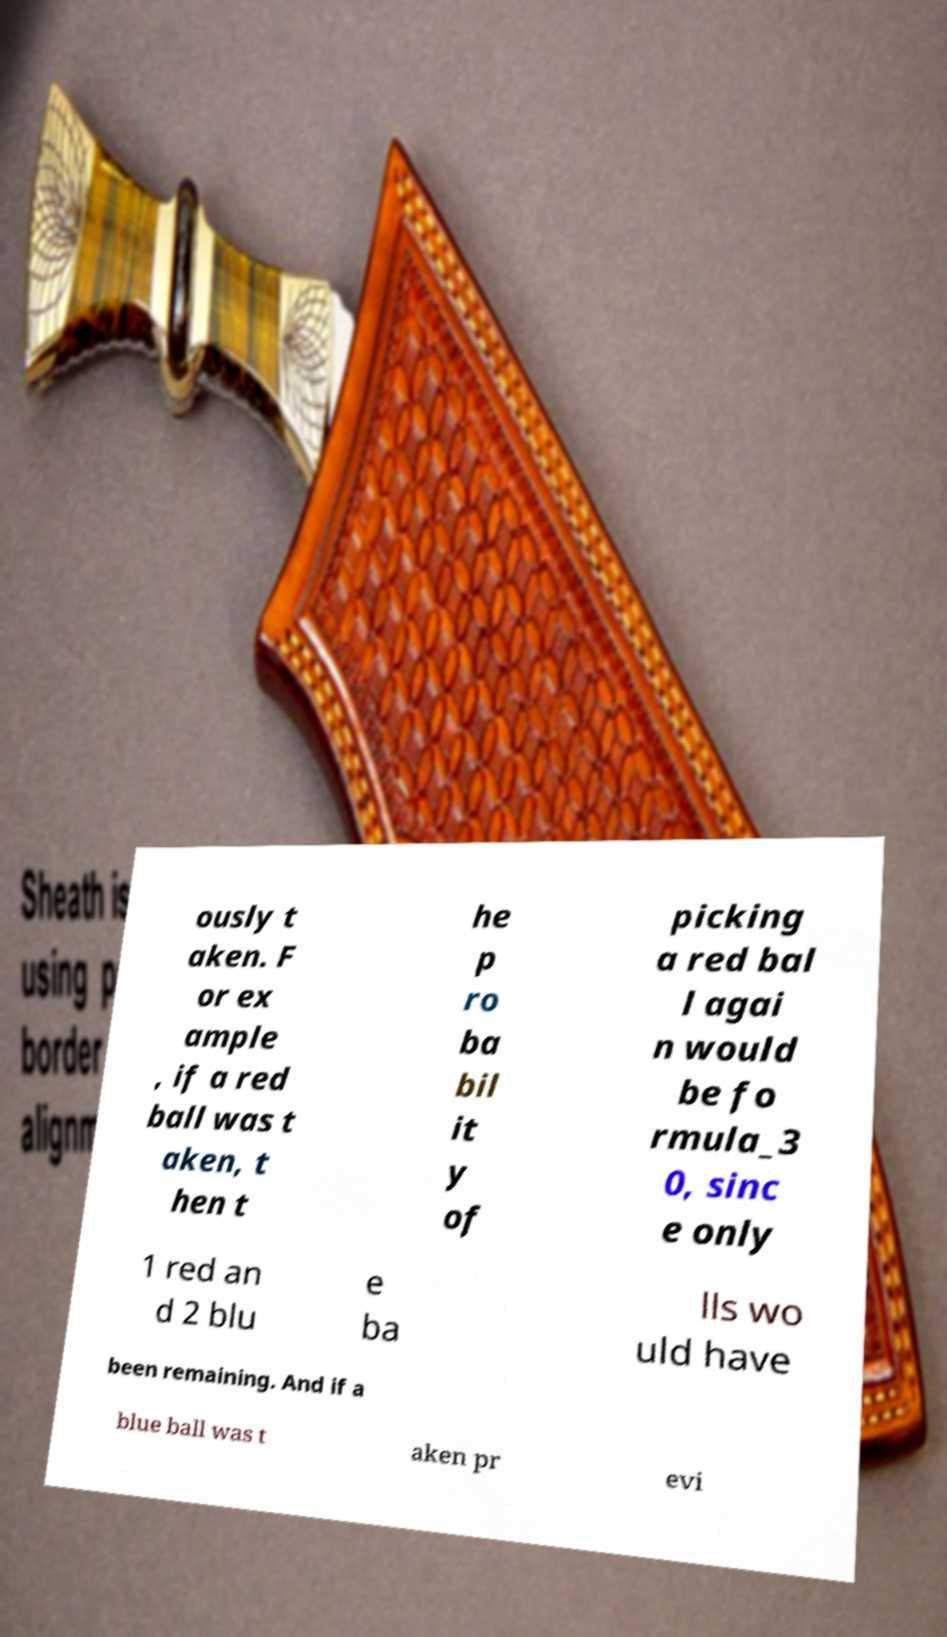Please identify and transcribe the text found in this image. ously t aken. F or ex ample , if a red ball was t aken, t hen t he p ro ba bil it y of picking a red bal l agai n would be fo rmula_3 0, sinc e only 1 red an d 2 blu e ba lls wo uld have been remaining. And if a blue ball was t aken pr evi 